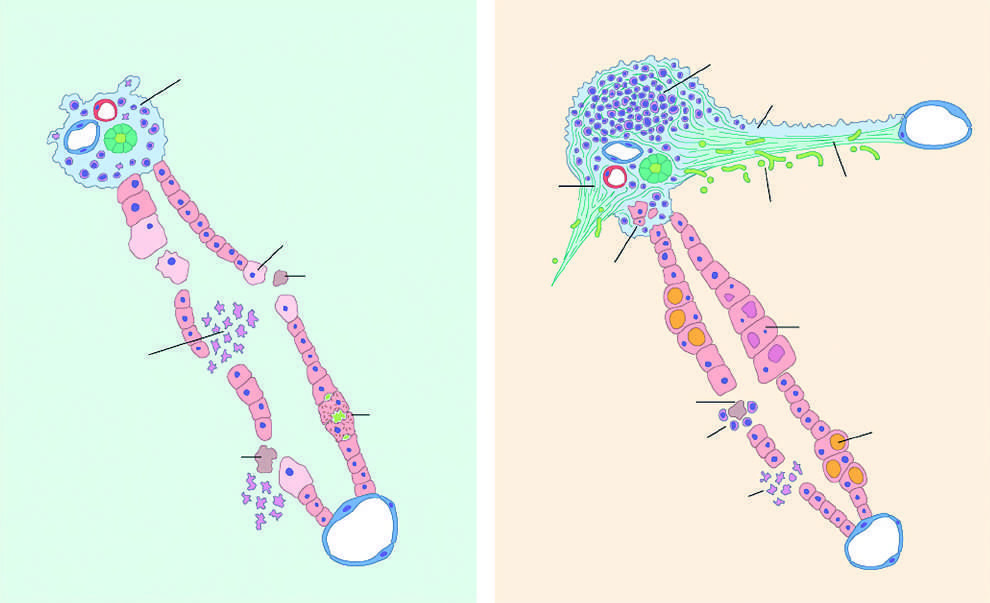how are portal infiltrates in chronic hepatitis?
Answer the question using a single word or phrase. Dense and prominent 